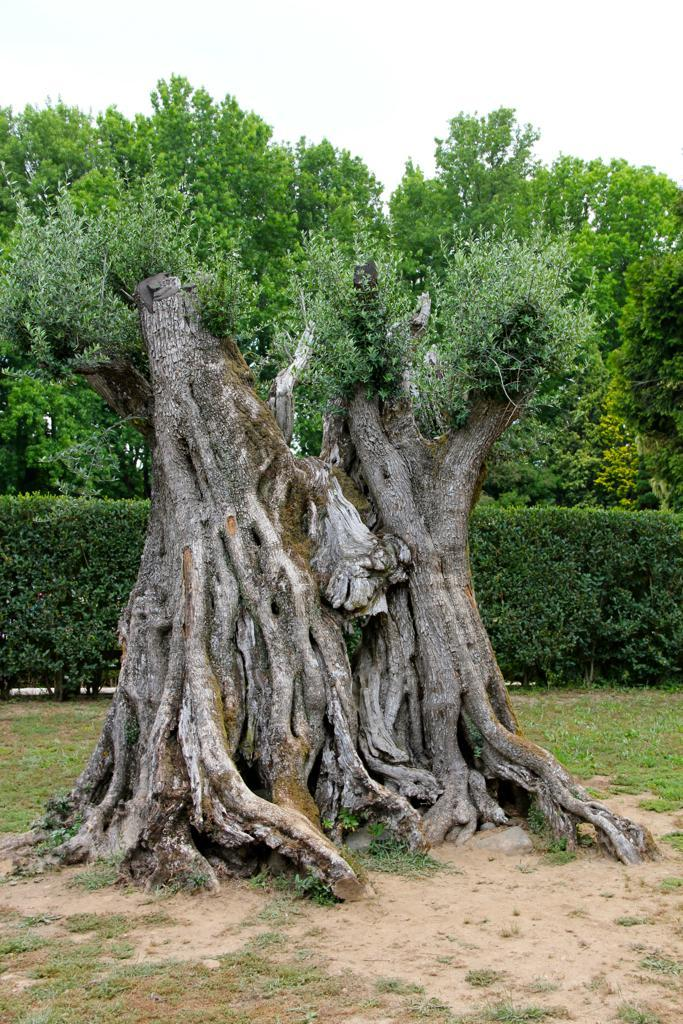What type of plant structure can be seen in the image? There is a tree stem in the image. What type of vegetation is present on the ground in the image? There is grass in the image. What other types of plants can be seen in the image? There are plants and trees in the image. What part of the natural environment is visible in the image? The sky is visible in the image. What angle is the fire burning at in the image? There is no fire present in the image, so it is not possible to determine the angle at which it might be burning. 